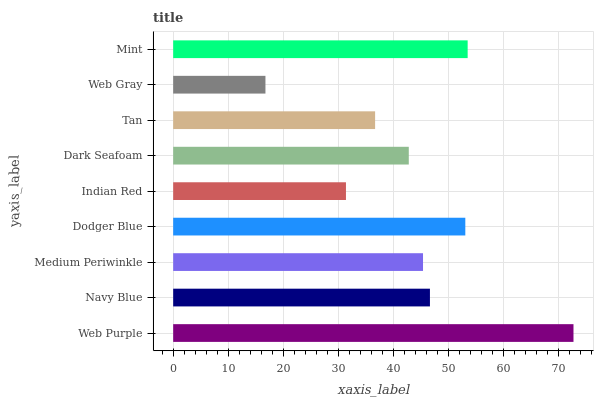Is Web Gray the minimum?
Answer yes or no. Yes. Is Web Purple the maximum?
Answer yes or no. Yes. Is Navy Blue the minimum?
Answer yes or no. No. Is Navy Blue the maximum?
Answer yes or no. No. Is Web Purple greater than Navy Blue?
Answer yes or no. Yes. Is Navy Blue less than Web Purple?
Answer yes or no. Yes. Is Navy Blue greater than Web Purple?
Answer yes or no. No. Is Web Purple less than Navy Blue?
Answer yes or no. No. Is Medium Periwinkle the high median?
Answer yes or no. Yes. Is Medium Periwinkle the low median?
Answer yes or no. Yes. Is Web Purple the high median?
Answer yes or no. No. Is Dodger Blue the low median?
Answer yes or no. No. 